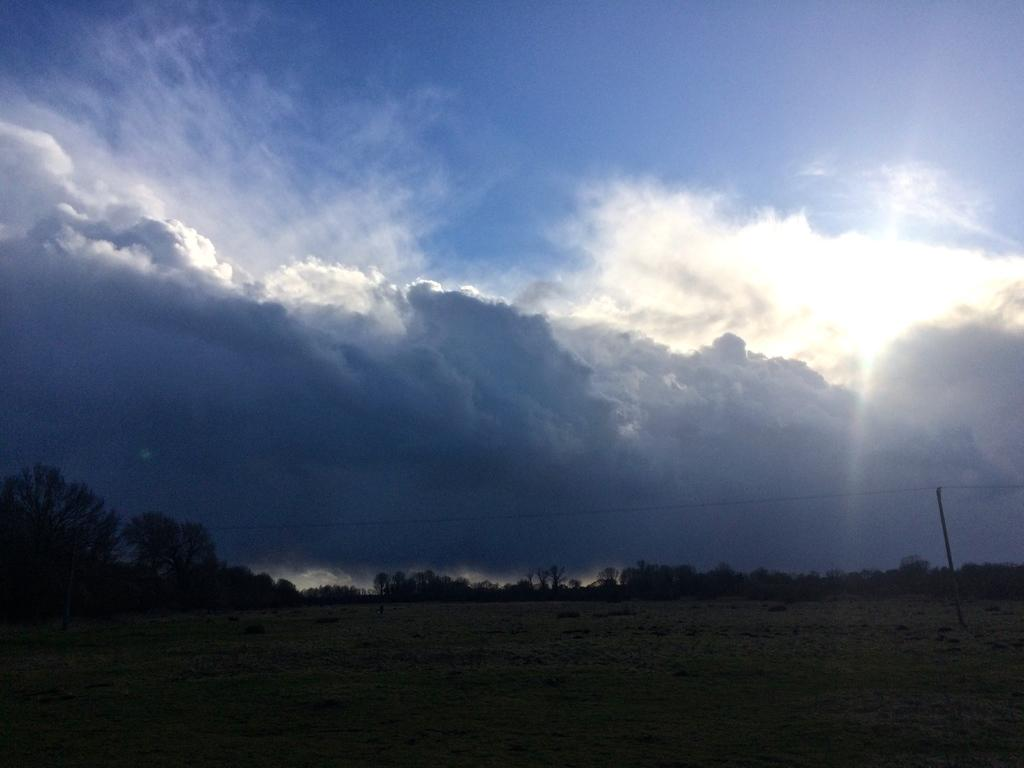What type of vegetation can be seen in the image? There are trees in the image. What structures are present in the image? There are poles in the image. What is visible in the sky at the top of the image? There are clouds in the sky at the top of the image. What is visible at the bottom of the image? There is ground visible at the bottom of the image. What type of drink is being served by the tree in the image? There is no tree serving a drink in the image; there are only trees and poles present. How many rings are visible on the tree in the image? There are no rings visible on the trees in the image, as trees do not have rings in this context. 